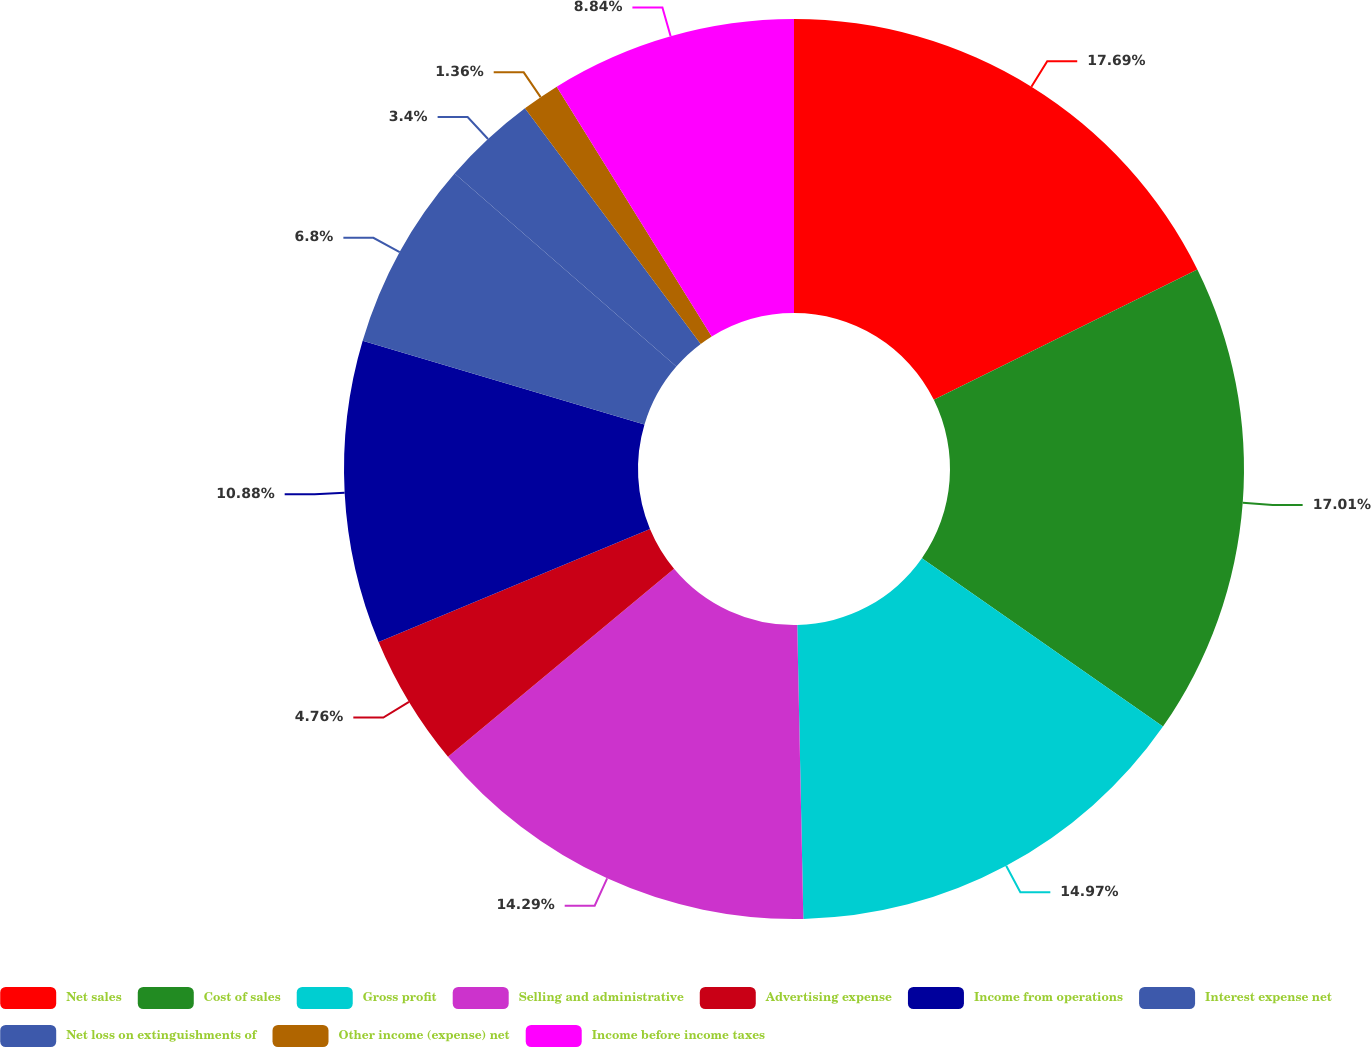Convert chart. <chart><loc_0><loc_0><loc_500><loc_500><pie_chart><fcel>Net sales<fcel>Cost of sales<fcel>Gross profit<fcel>Selling and administrative<fcel>Advertising expense<fcel>Income from operations<fcel>Interest expense net<fcel>Net loss on extinguishments of<fcel>Other income (expense) net<fcel>Income before income taxes<nl><fcel>17.69%<fcel>17.01%<fcel>14.97%<fcel>14.29%<fcel>4.76%<fcel>10.88%<fcel>6.8%<fcel>3.4%<fcel>1.36%<fcel>8.84%<nl></chart> 